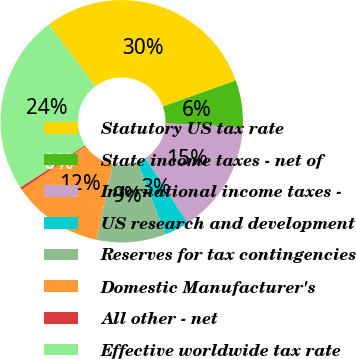Convert chart. <chart><loc_0><loc_0><loc_500><loc_500><pie_chart><fcel>Statutory US tax rate<fcel>State income taxes - net of<fcel>International income taxes -<fcel>US research and development<fcel>Reserves for tax contingencies<fcel>Domestic Manufacturer's<fcel>All other - net<fcel>Effective worldwide tax rate<nl><fcel>29.81%<fcel>6.24%<fcel>15.08%<fcel>3.29%<fcel>9.18%<fcel>12.13%<fcel>0.34%<fcel>23.94%<nl></chart> 